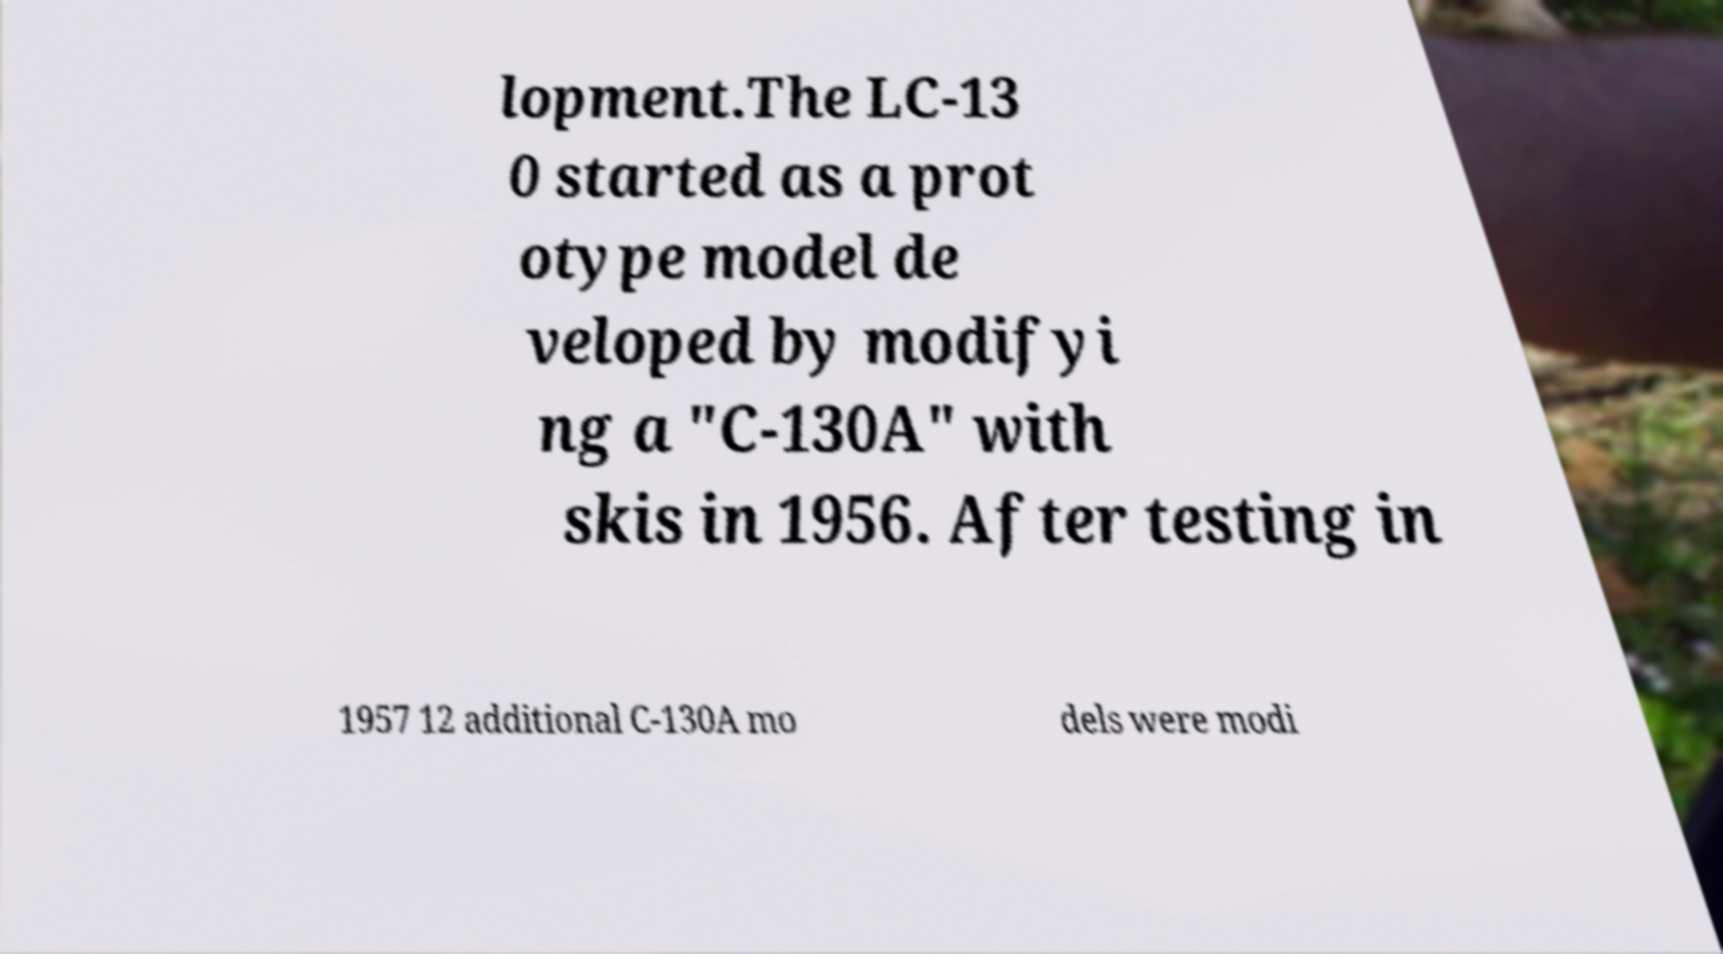Could you assist in decoding the text presented in this image and type it out clearly? lopment.The LC-13 0 started as a prot otype model de veloped by modifyi ng a "C-130A" with skis in 1956. After testing in 1957 12 additional C-130A mo dels were modi 